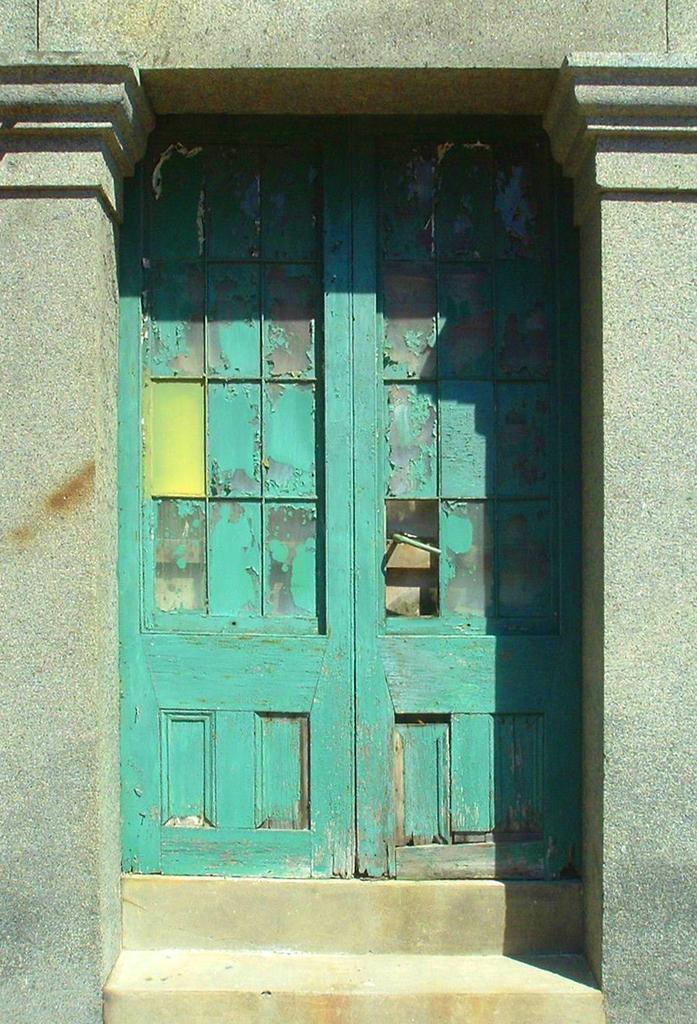Can you describe this image briefly? In this image we can see doors, steps and pillars. 